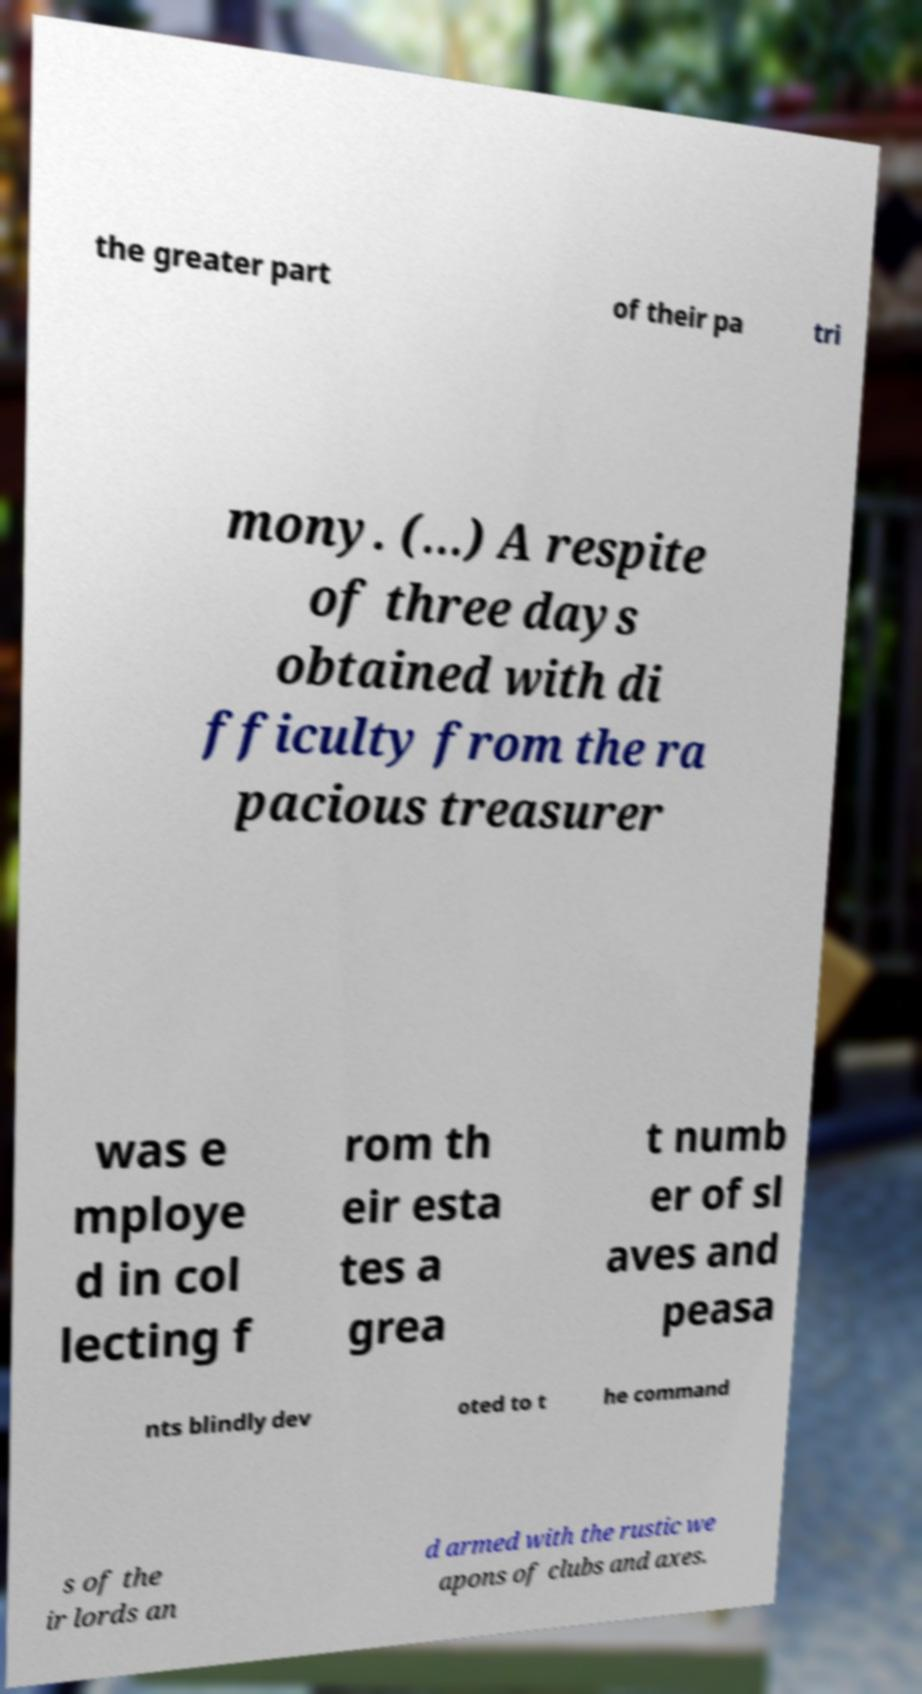Could you extract and type out the text from this image? the greater part of their pa tri mony. (…) A respite of three days obtained with di fficulty from the ra pacious treasurer was e mploye d in col lecting f rom th eir esta tes a grea t numb er of sl aves and peasa nts blindly dev oted to t he command s of the ir lords an d armed with the rustic we apons of clubs and axes. 